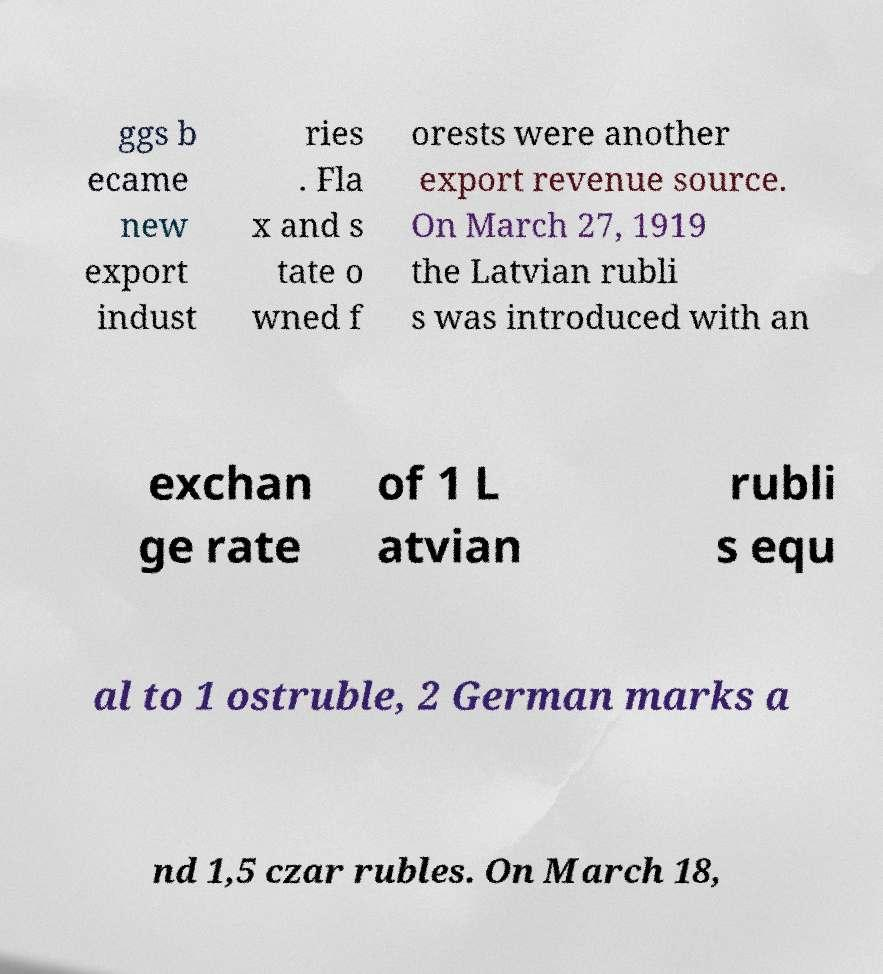I need the written content from this picture converted into text. Can you do that? ggs b ecame new export indust ries . Fla x and s tate o wned f orests were another export revenue source. On March 27, 1919 the Latvian rubli s was introduced with an exchan ge rate of 1 L atvian rubli s equ al to 1 ostruble, 2 German marks a nd 1,5 czar rubles. On March 18, 